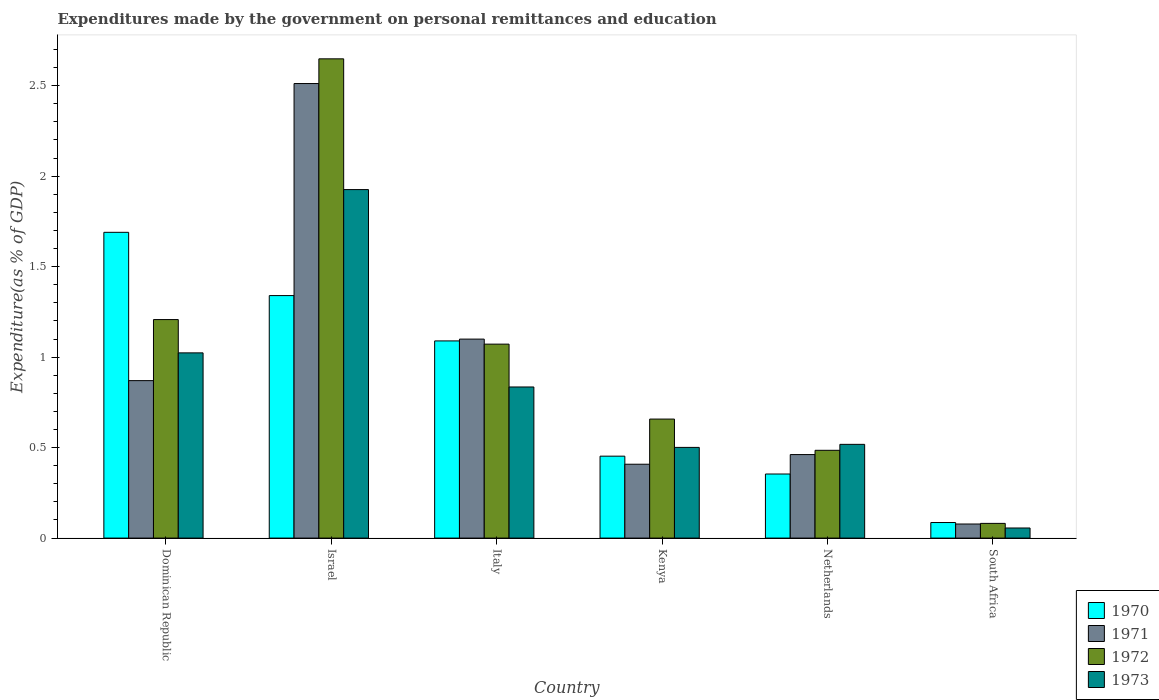How many different coloured bars are there?
Make the answer very short. 4. Are the number of bars per tick equal to the number of legend labels?
Your answer should be compact. Yes. Are the number of bars on each tick of the X-axis equal?
Ensure brevity in your answer.  Yes. How many bars are there on the 2nd tick from the right?
Your answer should be very brief. 4. What is the label of the 1st group of bars from the left?
Give a very brief answer. Dominican Republic. What is the expenditures made by the government on personal remittances and education in 1972 in Italy?
Provide a succinct answer. 1.07. Across all countries, what is the maximum expenditures made by the government on personal remittances and education in 1973?
Keep it short and to the point. 1.93. Across all countries, what is the minimum expenditures made by the government on personal remittances and education in 1970?
Offer a terse response. 0.09. In which country was the expenditures made by the government on personal remittances and education in 1972 minimum?
Your response must be concise. South Africa. What is the total expenditures made by the government on personal remittances and education in 1971 in the graph?
Make the answer very short. 5.43. What is the difference between the expenditures made by the government on personal remittances and education in 1973 in Dominican Republic and that in South Africa?
Keep it short and to the point. 0.97. What is the difference between the expenditures made by the government on personal remittances and education in 1970 in South Africa and the expenditures made by the government on personal remittances and education in 1973 in Kenya?
Offer a terse response. -0.42. What is the average expenditures made by the government on personal remittances and education in 1970 per country?
Keep it short and to the point. 0.84. What is the difference between the expenditures made by the government on personal remittances and education of/in 1970 and expenditures made by the government on personal remittances and education of/in 1971 in Israel?
Make the answer very short. -1.17. What is the ratio of the expenditures made by the government on personal remittances and education in 1970 in Netherlands to that in South Africa?
Provide a short and direct response. 4.12. What is the difference between the highest and the second highest expenditures made by the government on personal remittances and education in 1971?
Provide a succinct answer. -0.23. What is the difference between the highest and the lowest expenditures made by the government on personal remittances and education in 1971?
Provide a succinct answer. 2.43. What does the 2nd bar from the right in South Africa represents?
Keep it short and to the point. 1972. What is the difference between two consecutive major ticks on the Y-axis?
Your answer should be very brief. 0.5. Does the graph contain any zero values?
Give a very brief answer. No. How are the legend labels stacked?
Keep it short and to the point. Vertical. What is the title of the graph?
Offer a very short reply. Expenditures made by the government on personal remittances and education. Does "1976" appear as one of the legend labels in the graph?
Provide a short and direct response. No. What is the label or title of the X-axis?
Give a very brief answer. Country. What is the label or title of the Y-axis?
Offer a terse response. Expenditure(as % of GDP). What is the Expenditure(as % of GDP) of 1970 in Dominican Republic?
Provide a short and direct response. 1.69. What is the Expenditure(as % of GDP) of 1971 in Dominican Republic?
Make the answer very short. 0.87. What is the Expenditure(as % of GDP) of 1972 in Dominican Republic?
Keep it short and to the point. 1.21. What is the Expenditure(as % of GDP) in 1973 in Dominican Republic?
Your answer should be very brief. 1.02. What is the Expenditure(as % of GDP) of 1970 in Israel?
Make the answer very short. 1.34. What is the Expenditure(as % of GDP) of 1971 in Israel?
Offer a terse response. 2.51. What is the Expenditure(as % of GDP) in 1972 in Israel?
Make the answer very short. 2.65. What is the Expenditure(as % of GDP) of 1973 in Israel?
Your answer should be compact. 1.93. What is the Expenditure(as % of GDP) in 1970 in Italy?
Offer a terse response. 1.09. What is the Expenditure(as % of GDP) in 1971 in Italy?
Offer a terse response. 1.1. What is the Expenditure(as % of GDP) in 1972 in Italy?
Provide a short and direct response. 1.07. What is the Expenditure(as % of GDP) in 1973 in Italy?
Offer a terse response. 0.84. What is the Expenditure(as % of GDP) of 1970 in Kenya?
Your response must be concise. 0.45. What is the Expenditure(as % of GDP) of 1971 in Kenya?
Your answer should be compact. 0.41. What is the Expenditure(as % of GDP) of 1972 in Kenya?
Give a very brief answer. 0.66. What is the Expenditure(as % of GDP) of 1973 in Kenya?
Ensure brevity in your answer.  0.5. What is the Expenditure(as % of GDP) in 1970 in Netherlands?
Provide a succinct answer. 0.35. What is the Expenditure(as % of GDP) of 1971 in Netherlands?
Your response must be concise. 0.46. What is the Expenditure(as % of GDP) of 1972 in Netherlands?
Offer a terse response. 0.49. What is the Expenditure(as % of GDP) in 1973 in Netherlands?
Offer a terse response. 0.52. What is the Expenditure(as % of GDP) in 1970 in South Africa?
Offer a terse response. 0.09. What is the Expenditure(as % of GDP) in 1971 in South Africa?
Offer a very short reply. 0.08. What is the Expenditure(as % of GDP) in 1972 in South Africa?
Your answer should be very brief. 0.08. What is the Expenditure(as % of GDP) of 1973 in South Africa?
Ensure brevity in your answer.  0.06. Across all countries, what is the maximum Expenditure(as % of GDP) of 1970?
Give a very brief answer. 1.69. Across all countries, what is the maximum Expenditure(as % of GDP) in 1971?
Your answer should be very brief. 2.51. Across all countries, what is the maximum Expenditure(as % of GDP) of 1972?
Ensure brevity in your answer.  2.65. Across all countries, what is the maximum Expenditure(as % of GDP) of 1973?
Ensure brevity in your answer.  1.93. Across all countries, what is the minimum Expenditure(as % of GDP) in 1970?
Ensure brevity in your answer.  0.09. Across all countries, what is the minimum Expenditure(as % of GDP) of 1971?
Your answer should be compact. 0.08. Across all countries, what is the minimum Expenditure(as % of GDP) of 1972?
Your answer should be compact. 0.08. Across all countries, what is the minimum Expenditure(as % of GDP) in 1973?
Your answer should be very brief. 0.06. What is the total Expenditure(as % of GDP) in 1970 in the graph?
Provide a succinct answer. 5.01. What is the total Expenditure(as % of GDP) of 1971 in the graph?
Offer a very short reply. 5.43. What is the total Expenditure(as % of GDP) of 1972 in the graph?
Your response must be concise. 6.15. What is the total Expenditure(as % of GDP) of 1973 in the graph?
Ensure brevity in your answer.  4.86. What is the difference between the Expenditure(as % of GDP) of 1970 in Dominican Republic and that in Israel?
Offer a very short reply. 0.35. What is the difference between the Expenditure(as % of GDP) in 1971 in Dominican Republic and that in Israel?
Provide a short and direct response. -1.64. What is the difference between the Expenditure(as % of GDP) of 1972 in Dominican Republic and that in Israel?
Offer a terse response. -1.44. What is the difference between the Expenditure(as % of GDP) of 1973 in Dominican Republic and that in Israel?
Your response must be concise. -0.9. What is the difference between the Expenditure(as % of GDP) of 1970 in Dominican Republic and that in Italy?
Your answer should be very brief. 0.6. What is the difference between the Expenditure(as % of GDP) of 1971 in Dominican Republic and that in Italy?
Keep it short and to the point. -0.23. What is the difference between the Expenditure(as % of GDP) in 1972 in Dominican Republic and that in Italy?
Provide a succinct answer. 0.14. What is the difference between the Expenditure(as % of GDP) of 1973 in Dominican Republic and that in Italy?
Your answer should be compact. 0.19. What is the difference between the Expenditure(as % of GDP) of 1970 in Dominican Republic and that in Kenya?
Your response must be concise. 1.24. What is the difference between the Expenditure(as % of GDP) in 1971 in Dominican Republic and that in Kenya?
Your response must be concise. 0.46. What is the difference between the Expenditure(as % of GDP) of 1972 in Dominican Republic and that in Kenya?
Keep it short and to the point. 0.55. What is the difference between the Expenditure(as % of GDP) in 1973 in Dominican Republic and that in Kenya?
Make the answer very short. 0.52. What is the difference between the Expenditure(as % of GDP) of 1970 in Dominican Republic and that in Netherlands?
Your response must be concise. 1.34. What is the difference between the Expenditure(as % of GDP) of 1971 in Dominican Republic and that in Netherlands?
Your answer should be very brief. 0.41. What is the difference between the Expenditure(as % of GDP) of 1972 in Dominican Republic and that in Netherlands?
Ensure brevity in your answer.  0.72. What is the difference between the Expenditure(as % of GDP) of 1973 in Dominican Republic and that in Netherlands?
Provide a succinct answer. 0.51. What is the difference between the Expenditure(as % of GDP) of 1970 in Dominican Republic and that in South Africa?
Ensure brevity in your answer.  1.6. What is the difference between the Expenditure(as % of GDP) in 1971 in Dominican Republic and that in South Africa?
Provide a short and direct response. 0.79. What is the difference between the Expenditure(as % of GDP) of 1972 in Dominican Republic and that in South Africa?
Provide a short and direct response. 1.13. What is the difference between the Expenditure(as % of GDP) of 1973 in Dominican Republic and that in South Africa?
Your response must be concise. 0.97. What is the difference between the Expenditure(as % of GDP) of 1970 in Israel and that in Italy?
Ensure brevity in your answer.  0.25. What is the difference between the Expenditure(as % of GDP) of 1971 in Israel and that in Italy?
Provide a short and direct response. 1.41. What is the difference between the Expenditure(as % of GDP) of 1972 in Israel and that in Italy?
Your answer should be very brief. 1.58. What is the difference between the Expenditure(as % of GDP) in 1973 in Israel and that in Italy?
Provide a short and direct response. 1.09. What is the difference between the Expenditure(as % of GDP) in 1970 in Israel and that in Kenya?
Your response must be concise. 0.89. What is the difference between the Expenditure(as % of GDP) of 1971 in Israel and that in Kenya?
Your response must be concise. 2.1. What is the difference between the Expenditure(as % of GDP) of 1972 in Israel and that in Kenya?
Offer a very short reply. 1.99. What is the difference between the Expenditure(as % of GDP) in 1973 in Israel and that in Kenya?
Your response must be concise. 1.42. What is the difference between the Expenditure(as % of GDP) in 1970 in Israel and that in Netherlands?
Your response must be concise. 0.99. What is the difference between the Expenditure(as % of GDP) of 1971 in Israel and that in Netherlands?
Ensure brevity in your answer.  2.05. What is the difference between the Expenditure(as % of GDP) of 1972 in Israel and that in Netherlands?
Offer a very short reply. 2.16. What is the difference between the Expenditure(as % of GDP) in 1973 in Israel and that in Netherlands?
Your answer should be compact. 1.41. What is the difference between the Expenditure(as % of GDP) of 1970 in Israel and that in South Africa?
Provide a succinct answer. 1.25. What is the difference between the Expenditure(as % of GDP) of 1971 in Israel and that in South Africa?
Your response must be concise. 2.43. What is the difference between the Expenditure(as % of GDP) of 1972 in Israel and that in South Africa?
Provide a short and direct response. 2.57. What is the difference between the Expenditure(as % of GDP) in 1973 in Israel and that in South Africa?
Offer a very short reply. 1.87. What is the difference between the Expenditure(as % of GDP) of 1970 in Italy and that in Kenya?
Your response must be concise. 0.64. What is the difference between the Expenditure(as % of GDP) in 1971 in Italy and that in Kenya?
Offer a terse response. 0.69. What is the difference between the Expenditure(as % of GDP) of 1972 in Italy and that in Kenya?
Offer a very short reply. 0.41. What is the difference between the Expenditure(as % of GDP) of 1973 in Italy and that in Kenya?
Ensure brevity in your answer.  0.33. What is the difference between the Expenditure(as % of GDP) of 1970 in Italy and that in Netherlands?
Offer a very short reply. 0.74. What is the difference between the Expenditure(as % of GDP) in 1971 in Italy and that in Netherlands?
Offer a terse response. 0.64. What is the difference between the Expenditure(as % of GDP) of 1972 in Italy and that in Netherlands?
Keep it short and to the point. 0.59. What is the difference between the Expenditure(as % of GDP) in 1973 in Italy and that in Netherlands?
Provide a short and direct response. 0.32. What is the difference between the Expenditure(as % of GDP) in 1971 in Italy and that in South Africa?
Make the answer very short. 1.02. What is the difference between the Expenditure(as % of GDP) in 1972 in Italy and that in South Africa?
Provide a succinct answer. 0.99. What is the difference between the Expenditure(as % of GDP) in 1973 in Italy and that in South Africa?
Provide a succinct answer. 0.78. What is the difference between the Expenditure(as % of GDP) in 1970 in Kenya and that in Netherlands?
Your answer should be very brief. 0.1. What is the difference between the Expenditure(as % of GDP) in 1971 in Kenya and that in Netherlands?
Your answer should be compact. -0.05. What is the difference between the Expenditure(as % of GDP) in 1972 in Kenya and that in Netherlands?
Provide a short and direct response. 0.17. What is the difference between the Expenditure(as % of GDP) in 1973 in Kenya and that in Netherlands?
Your answer should be very brief. -0.02. What is the difference between the Expenditure(as % of GDP) in 1970 in Kenya and that in South Africa?
Make the answer very short. 0.37. What is the difference between the Expenditure(as % of GDP) in 1971 in Kenya and that in South Africa?
Offer a very short reply. 0.33. What is the difference between the Expenditure(as % of GDP) in 1972 in Kenya and that in South Africa?
Ensure brevity in your answer.  0.58. What is the difference between the Expenditure(as % of GDP) of 1973 in Kenya and that in South Africa?
Provide a succinct answer. 0.45. What is the difference between the Expenditure(as % of GDP) in 1970 in Netherlands and that in South Africa?
Offer a terse response. 0.27. What is the difference between the Expenditure(as % of GDP) of 1971 in Netherlands and that in South Africa?
Offer a terse response. 0.38. What is the difference between the Expenditure(as % of GDP) of 1972 in Netherlands and that in South Africa?
Your answer should be very brief. 0.4. What is the difference between the Expenditure(as % of GDP) of 1973 in Netherlands and that in South Africa?
Your answer should be compact. 0.46. What is the difference between the Expenditure(as % of GDP) of 1970 in Dominican Republic and the Expenditure(as % of GDP) of 1971 in Israel?
Make the answer very short. -0.82. What is the difference between the Expenditure(as % of GDP) of 1970 in Dominican Republic and the Expenditure(as % of GDP) of 1972 in Israel?
Offer a very short reply. -0.96. What is the difference between the Expenditure(as % of GDP) of 1970 in Dominican Republic and the Expenditure(as % of GDP) of 1973 in Israel?
Your answer should be very brief. -0.24. What is the difference between the Expenditure(as % of GDP) of 1971 in Dominican Republic and the Expenditure(as % of GDP) of 1972 in Israel?
Give a very brief answer. -1.78. What is the difference between the Expenditure(as % of GDP) of 1971 in Dominican Republic and the Expenditure(as % of GDP) of 1973 in Israel?
Provide a short and direct response. -1.06. What is the difference between the Expenditure(as % of GDP) in 1972 in Dominican Republic and the Expenditure(as % of GDP) in 1973 in Israel?
Make the answer very short. -0.72. What is the difference between the Expenditure(as % of GDP) in 1970 in Dominican Republic and the Expenditure(as % of GDP) in 1971 in Italy?
Offer a terse response. 0.59. What is the difference between the Expenditure(as % of GDP) in 1970 in Dominican Republic and the Expenditure(as % of GDP) in 1972 in Italy?
Offer a terse response. 0.62. What is the difference between the Expenditure(as % of GDP) in 1970 in Dominican Republic and the Expenditure(as % of GDP) in 1973 in Italy?
Provide a short and direct response. 0.85. What is the difference between the Expenditure(as % of GDP) in 1971 in Dominican Republic and the Expenditure(as % of GDP) in 1972 in Italy?
Ensure brevity in your answer.  -0.2. What is the difference between the Expenditure(as % of GDP) of 1971 in Dominican Republic and the Expenditure(as % of GDP) of 1973 in Italy?
Offer a terse response. 0.04. What is the difference between the Expenditure(as % of GDP) of 1972 in Dominican Republic and the Expenditure(as % of GDP) of 1973 in Italy?
Offer a very short reply. 0.37. What is the difference between the Expenditure(as % of GDP) in 1970 in Dominican Republic and the Expenditure(as % of GDP) in 1971 in Kenya?
Ensure brevity in your answer.  1.28. What is the difference between the Expenditure(as % of GDP) in 1970 in Dominican Republic and the Expenditure(as % of GDP) in 1972 in Kenya?
Ensure brevity in your answer.  1.03. What is the difference between the Expenditure(as % of GDP) in 1970 in Dominican Republic and the Expenditure(as % of GDP) in 1973 in Kenya?
Make the answer very short. 1.19. What is the difference between the Expenditure(as % of GDP) of 1971 in Dominican Republic and the Expenditure(as % of GDP) of 1972 in Kenya?
Your response must be concise. 0.21. What is the difference between the Expenditure(as % of GDP) in 1971 in Dominican Republic and the Expenditure(as % of GDP) in 1973 in Kenya?
Keep it short and to the point. 0.37. What is the difference between the Expenditure(as % of GDP) in 1972 in Dominican Republic and the Expenditure(as % of GDP) in 1973 in Kenya?
Ensure brevity in your answer.  0.71. What is the difference between the Expenditure(as % of GDP) of 1970 in Dominican Republic and the Expenditure(as % of GDP) of 1971 in Netherlands?
Make the answer very short. 1.23. What is the difference between the Expenditure(as % of GDP) of 1970 in Dominican Republic and the Expenditure(as % of GDP) of 1972 in Netherlands?
Offer a terse response. 1.2. What is the difference between the Expenditure(as % of GDP) of 1970 in Dominican Republic and the Expenditure(as % of GDP) of 1973 in Netherlands?
Your answer should be very brief. 1.17. What is the difference between the Expenditure(as % of GDP) of 1971 in Dominican Republic and the Expenditure(as % of GDP) of 1972 in Netherlands?
Your response must be concise. 0.39. What is the difference between the Expenditure(as % of GDP) in 1971 in Dominican Republic and the Expenditure(as % of GDP) in 1973 in Netherlands?
Offer a terse response. 0.35. What is the difference between the Expenditure(as % of GDP) in 1972 in Dominican Republic and the Expenditure(as % of GDP) in 1973 in Netherlands?
Offer a very short reply. 0.69. What is the difference between the Expenditure(as % of GDP) in 1970 in Dominican Republic and the Expenditure(as % of GDP) in 1971 in South Africa?
Your answer should be very brief. 1.61. What is the difference between the Expenditure(as % of GDP) of 1970 in Dominican Republic and the Expenditure(as % of GDP) of 1972 in South Africa?
Ensure brevity in your answer.  1.61. What is the difference between the Expenditure(as % of GDP) of 1970 in Dominican Republic and the Expenditure(as % of GDP) of 1973 in South Africa?
Your answer should be compact. 1.63. What is the difference between the Expenditure(as % of GDP) in 1971 in Dominican Republic and the Expenditure(as % of GDP) in 1972 in South Africa?
Make the answer very short. 0.79. What is the difference between the Expenditure(as % of GDP) in 1971 in Dominican Republic and the Expenditure(as % of GDP) in 1973 in South Africa?
Your response must be concise. 0.81. What is the difference between the Expenditure(as % of GDP) of 1972 in Dominican Republic and the Expenditure(as % of GDP) of 1973 in South Africa?
Your answer should be very brief. 1.15. What is the difference between the Expenditure(as % of GDP) in 1970 in Israel and the Expenditure(as % of GDP) in 1971 in Italy?
Make the answer very short. 0.24. What is the difference between the Expenditure(as % of GDP) of 1970 in Israel and the Expenditure(as % of GDP) of 1972 in Italy?
Offer a very short reply. 0.27. What is the difference between the Expenditure(as % of GDP) in 1970 in Israel and the Expenditure(as % of GDP) in 1973 in Italy?
Your answer should be very brief. 0.51. What is the difference between the Expenditure(as % of GDP) in 1971 in Israel and the Expenditure(as % of GDP) in 1972 in Italy?
Make the answer very short. 1.44. What is the difference between the Expenditure(as % of GDP) in 1971 in Israel and the Expenditure(as % of GDP) in 1973 in Italy?
Provide a short and direct response. 1.68. What is the difference between the Expenditure(as % of GDP) of 1972 in Israel and the Expenditure(as % of GDP) of 1973 in Italy?
Your answer should be compact. 1.81. What is the difference between the Expenditure(as % of GDP) in 1970 in Israel and the Expenditure(as % of GDP) in 1971 in Kenya?
Keep it short and to the point. 0.93. What is the difference between the Expenditure(as % of GDP) in 1970 in Israel and the Expenditure(as % of GDP) in 1972 in Kenya?
Provide a succinct answer. 0.68. What is the difference between the Expenditure(as % of GDP) of 1970 in Israel and the Expenditure(as % of GDP) of 1973 in Kenya?
Your answer should be very brief. 0.84. What is the difference between the Expenditure(as % of GDP) in 1971 in Israel and the Expenditure(as % of GDP) in 1972 in Kenya?
Offer a very short reply. 1.85. What is the difference between the Expenditure(as % of GDP) of 1971 in Israel and the Expenditure(as % of GDP) of 1973 in Kenya?
Provide a short and direct response. 2.01. What is the difference between the Expenditure(as % of GDP) of 1972 in Israel and the Expenditure(as % of GDP) of 1973 in Kenya?
Your answer should be very brief. 2.15. What is the difference between the Expenditure(as % of GDP) of 1970 in Israel and the Expenditure(as % of GDP) of 1971 in Netherlands?
Your answer should be very brief. 0.88. What is the difference between the Expenditure(as % of GDP) of 1970 in Israel and the Expenditure(as % of GDP) of 1972 in Netherlands?
Your answer should be very brief. 0.85. What is the difference between the Expenditure(as % of GDP) in 1970 in Israel and the Expenditure(as % of GDP) in 1973 in Netherlands?
Ensure brevity in your answer.  0.82. What is the difference between the Expenditure(as % of GDP) in 1971 in Israel and the Expenditure(as % of GDP) in 1972 in Netherlands?
Offer a terse response. 2.03. What is the difference between the Expenditure(as % of GDP) in 1971 in Israel and the Expenditure(as % of GDP) in 1973 in Netherlands?
Give a very brief answer. 1.99. What is the difference between the Expenditure(as % of GDP) in 1972 in Israel and the Expenditure(as % of GDP) in 1973 in Netherlands?
Provide a short and direct response. 2.13. What is the difference between the Expenditure(as % of GDP) of 1970 in Israel and the Expenditure(as % of GDP) of 1971 in South Africa?
Offer a very short reply. 1.26. What is the difference between the Expenditure(as % of GDP) in 1970 in Israel and the Expenditure(as % of GDP) in 1972 in South Africa?
Keep it short and to the point. 1.26. What is the difference between the Expenditure(as % of GDP) in 1970 in Israel and the Expenditure(as % of GDP) in 1973 in South Africa?
Provide a short and direct response. 1.28. What is the difference between the Expenditure(as % of GDP) in 1971 in Israel and the Expenditure(as % of GDP) in 1972 in South Africa?
Your answer should be compact. 2.43. What is the difference between the Expenditure(as % of GDP) of 1971 in Israel and the Expenditure(as % of GDP) of 1973 in South Africa?
Your response must be concise. 2.46. What is the difference between the Expenditure(as % of GDP) of 1972 in Israel and the Expenditure(as % of GDP) of 1973 in South Africa?
Offer a very short reply. 2.59. What is the difference between the Expenditure(as % of GDP) of 1970 in Italy and the Expenditure(as % of GDP) of 1971 in Kenya?
Your answer should be compact. 0.68. What is the difference between the Expenditure(as % of GDP) in 1970 in Italy and the Expenditure(as % of GDP) in 1972 in Kenya?
Keep it short and to the point. 0.43. What is the difference between the Expenditure(as % of GDP) in 1970 in Italy and the Expenditure(as % of GDP) in 1973 in Kenya?
Your answer should be compact. 0.59. What is the difference between the Expenditure(as % of GDP) in 1971 in Italy and the Expenditure(as % of GDP) in 1972 in Kenya?
Your response must be concise. 0.44. What is the difference between the Expenditure(as % of GDP) of 1971 in Italy and the Expenditure(as % of GDP) of 1973 in Kenya?
Provide a short and direct response. 0.6. What is the difference between the Expenditure(as % of GDP) of 1972 in Italy and the Expenditure(as % of GDP) of 1973 in Kenya?
Provide a succinct answer. 0.57. What is the difference between the Expenditure(as % of GDP) of 1970 in Italy and the Expenditure(as % of GDP) of 1971 in Netherlands?
Keep it short and to the point. 0.63. What is the difference between the Expenditure(as % of GDP) of 1970 in Italy and the Expenditure(as % of GDP) of 1972 in Netherlands?
Offer a terse response. 0.6. What is the difference between the Expenditure(as % of GDP) of 1970 in Italy and the Expenditure(as % of GDP) of 1973 in Netherlands?
Keep it short and to the point. 0.57. What is the difference between the Expenditure(as % of GDP) in 1971 in Italy and the Expenditure(as % of GDP) in 1972 in Netherlands?
Make the answer very short. 0.61. What is the difference between the Expenditure(as % of GDP) of 1971 in Italy and the Expenditure(as % of GDP) of 1973 in Netherlands?
Keep it short and to the point. 0.58. What is the difference between the Expenditure(as % of GDP) of 1972 in Italy and the Expenditure(as % of GDP) of 1973 in Netherlands?
Keep it short and to the point. 0.55. What is the difference between the Expenditure(as % of GDP) in 1970 in Italy and the Expenditure(as % of GDP) in 1971 in South Africa?
Ensure brevity in your answer.  1.01. What is the difference between the Expenditure(as % of GDP) of 1970 in Italy and the Expenditure(as % of GDP) of 1972 in South Africa?
Your answer should be very brief. 1.01. What is the difference between the Expenditure(as % of GDP) in 1970 in Italy and the Expenditure(as % of GDP) in 1973 in South Africa?
Make the answer very short. 1.03. What is the difference between the Expenditure(as % of GDP) of 1971 in Italy and the Expenditure(as % of GDP) of 1972 in South Africa?
Offer a very short reply. 1.02. What is the difference between the Expenditure(as % of GDP) in 1971 in Italy and the Expenditure(as % of GDP) in 1973 in South Africa?
Offer a terse response. 1.04. What is the difference between the Expenditure(as % of GDP) of 1972 in Italy and the Expenditure(as % of GDP) of 1973 in South Africa?
Your answer should be very brief. 1.02. What is the difference between the Expenditure(as % of GDP) of 1970 in Kenya and the Expenditure(as % of GDP) of 1971 in Netherlands?
Your answer should be very brief. -0.01. What is the difference between the Expenditure(as % of GDP) of 1970 in Kenya and the Expenditure(as % of GDP) of 1972 in Netherlands?
Ensure brevity in your answer.  -0.03. What is the difference between the Expenditure(as % of GDP) in 1970 in Kenya and the Expenditure(as % of GDP) in 1973 in Netherlands?
Provide a short and direct response. -0.07. What is the difference between the Expenditure(as % of GDP) in 1971 in Kenya and the Expenditure(as % of GDP) in 1972 in Netherlands?
Your answer should be compact. -0.08. What is the difference between the Expenditure(as % of GDP) of 1971 in Kenya and the Expenditure(as % of GDP) of 1973 in Netherlands?
Ensure brevity in your answer.  -0.11. What is the difference between the Expenditure(as % of GDP) of 1972 in Kenya and the Expenditure(as % of GDP) of 1973 in Netherlands?
Provide a short and direct response. 0.14. What is the difference between the Expenditure(as % of GDP) of 1970 in Kenya and the Expenditure(as % of GDP) of 1972 in South Africa?
Your answer should be very brief. 0.37. What is the difference between the Expenditure(as % of GDP) in 1970 in Kenya and the Expenditure(as % of GDP) in 1973 in South Africa?
Offer a very short reply. 0.4. What is the difference between the Expenditure(as % of GDP) of 1971 in Kenya and the Expenditure(as % of GDP) of 1972 in South Africa?
Offer a terse response. 0.33. What is the difference between the Expenditure(as % of GDP) in 1971 in Kenya and the Expenditure(as % of GDP) in 1973 in South Africa?
Provide a succinct answer. 0.35. What is the difference between the Expenditure(as % of GDP) of 1972 in Kenya and the Expenditure(as % of GDP) of 1973 in South Africa?
Provide a succinct answer. 0.6. What is the difference between the Expenditure(as % of GDP) in 1970 in Netherlands and the Expenditure(as % of GDP) in 1971 in South Africa?
Provide a short and direct response. 0.28. What is the difference between the Expenditure(as % of GDP) in 1970 in Netherlands and the Expenditure(as % of GDP) in 1972 in South Africa?
Ensure brevity in your answer.  0.27. What is the difference between the Expenditure(as % of GDP) of 1970 in Netherlands and the Expenditure(as % of GDP) of 1973 in South Africa?
Your answer should be very brief. 0.3. What is the difference between the Expenditure(as % of GDP) of 1971 in Netherlands and the Expenditure(as % of GDP) of 1972 in South Africa?
Offer a very short reply. 0.38. What is the difference between the Expenditure(as % of GDP) in 1971 in Netherlands and the Expenditure(as % of GDP) in 1973 in South Africa?
Your answer should be compact. 0.41. What is the difference between the Expenditure(as % of GDP) of 1972 in Netherlands and the Expenditure(as % of GDP) of 1973 in South Africa?
Offer a very short reply. 0.43. What is the average Expenditure(as % of GDP) in 1970 per country?
Your answer should be compact. 0.84. What is the average Expenditure(as % of GDP) in 1971 per country?
Make the answer very short. 0.9. What is the average Expenditure(as % of GDP) of 1972 per country?
Make the answer very short. 1.03. What is the average Expenditure(as % of GDP) in 1973 per country?
Provide a succinct answer. 0.81. What is the difference between the Expenditure(as % of GDP) of 1970 and Expenditure(as % of GDP) of 1971 in Dominican Republic?
Offer a terse response. 0.82. What is the difference between the Expenditure(as % of GDP) of 1970 and Expenditure(as % of GDP) of 1972 in Dominican Republic?
Give a very brief answer. 0.48. What is the difference between the Expenditure(as % of GDP) in 1970 and Expenditure(as % of GDP) in 1973 in Dominican Republic?
Your response must be concise. 0.67. What is the difference between the Expenditure(as % of GDP) of 1971 and Expenditure(as % of GDP) of 1972 in Dominican Republic?
Offer a terse response. -0.34. What is the difference between the Expenditure(as % of GDP) in 1971 and Expenditure(as % of GDP) in 1973 in Dominican Republic?
Keep it short and to the point. -0.15. What is the difference between the Expenditure(as % of GDP) in 1972 and Expenditure(as % of GDP) in 1973 in Dominican Republic?
Offer a terse response. 0.18. What is the difference between the Expenditure(as % of GDP) of 1970 and Expenditure(as % of GDP) of 1971 in Israel?
Make the answer very short. -1.17. What is the difference between the Expenditure(as % of GDP) of 1970 and Expenditure(as % of GDP) of 1972 in Israel?
Ensure brevity in your answer.  -1.31. What is the difference between the Expenditure(as % of GDP) in 1970 and Expenditure(as % of GDP) in 1973 in Israel?
Give a very brief answer. -0.59. What is the difference between the Expenditure(as % of GDP) in 1971 and Expenditure(as % of GDP) in 1972 in Israel?
Your answer should be very brief. -0.14. What is the difference between the Expenditure(as % of GDP) in 1971 and Expenditure(as % of GDP) in 1973 in Israel?
Offer a terse response. 0.59. What is the difference between the Expenditure(as % of GDP) in 1972 and Expenditure(as % of GDP) in 1973 in Israel?
Keep it short and to the point. 0.72. What is the difference between the Expenditure(as % of GDP) in 1970 and Expenditure(as % of GDP) in 1971 in Italy?
Offer a terse response. -0.01. What is the difference between the Expenditure(as % of GDP) of 1970 and Expenditure(as % of GDP) of 1972 in Italy?
Provide a succinct answer. 0.02. What is the difference between the Expenditure(as % of GDP) of 1970 and Expenditure(as % of GDP) of 1973 in Italy?
Your answer should be very brief. 0.25. What is the difference between the Expenditure(as % of GDP) in 1971 and Expenditure(as % of GDP) in 1972 in Italy?
Offer a very short reply. 0.03. What is the difference between the Expenditure(as % of GDP) of 1971 and Expenditure(as % of GDP) of 1973 in Italy?
Offer a terse response. 0.26. What is the difference between the Expenditure(as % of GDP) in 1972 and Expenditure(as % of GDP) in 1973 in Italy?
Ensure brevity in your answer.  0.24. What is the difference between the Expenditure(as % of GDP) of 1970 and Expenditure(as % of GDP) of 1971 in Kenya?
Ensure brevity in your answer.  0.04. What is the difference between the Expenditure(as % of GDP) in 1970 and Expenditure(as % of GDP) in 1972 in Kenya?
Offer a very short reply. -0.2. What is the difference between the Expenditure(as % of GDP) in 1970 and Expenditure(as % of GDP) in 1973 in Kenya?
Your response must be concise. -0.05. What is the difference between the Expenditure(as % of GDP) in 1971 and Expenditure(as % of GDP) in 1972 in Kenya?
Ensure brevity in your answer.  -0.25. What is the difference between the Expenditure(as % of GDP) in 1971 and Expenditure(as % of GDP) in 1973 in Kenya?
Ensure brevity in your answer.  -0.09. What is the difference between the Expenditure(as % of GDP) of 1972 and Expenditure(as % of GDP) of 1973 in Kenya?
Offer a terse response. 0.16. What is the difference between the Expenditure(as % of GDP) of 1970 and Expenditure(as % of GDP) of 1971 in Netherlands?
Provide a succinct answer. -0.11. What is the difference between the Expenditure(as % of GDP) of 1970 and Expenditure(as % of GDP) of 1972 in Netherlands?
Keep it short and to the point. -0.13. What is the difference between the Expenditure(as % of GDP) in 1970 and Expenditure(as % of GDP) in 1973 in Netherlands?
Make the answer very short. -0.16. What is the difference between the Expenditure(as % of GDP) of 1971 and Expenditure(as % of GDP) of 1972 in Netherlands?
Your answer should be very brief. -0.02. What is the difference between the Expenditure(as % of GDP) in 1971 and Expenditure(as % of GDP) in 1973 in Netherlands?
Your answer should be compact. -0.06. What is the difference between the Expenditure(as % of GDP) of 1972 and Expenditure(as % of GDP) of 1973 in Netherlands?
Provide a short and direct response. -0.03. What is the difference between the Expenditure(as % of GDP) in 1970 and Expenditure(as % of GDP) in 1971 in South Africa?
Offer a terse response. 0.01. What is the difference between the Expenditure(as % of GDP) in 1970 and Expenditure(as % of GDP) in 1972 in South Africa?
Ensure brevity in your answer.  0. What is the difference between the Expenditure(as % of GDP) of 1970 and Expenditure(as % of GDP) of 1973 in South Africa?
Your answer should be very brief. 0.03. What is the difference between the Expenditure(as % of GDP) in 1971 and Expenditure(as % of GDP) in 1972 in South Africa?
Ensure brevity in your answer.  -0. What is the difference between the Expenditure(as % of GDP) in 1971 and Expenditure(as % of GDP) in 1973 in South Africa?
Give a very brief answer. 0.02. What is the difference between the Expenditure(as % of GDP) in 1972 and Expenditure(as % of GDP) in 1973 in South Africa?
Provide a succinct answer. 0.03. What is the ratio of the Expenditure(as % of GDP) in 1970 in Dominican Republic to that in Israel?
Give a very brief answer. 1.26. What is the ratio of the Expenditure(as % of GDP) in 1971 in Dominican Republic to that in Israel?
Your answer should be compact. 0.35. What is the ratio of the Expenditure(as % of GDP) in 1972 in Dominican Republic to that in Israel?
Provide a short and direct response. 0.46. What is the ratio of the Expenditure(as % of GDP) of 1973 in Dominican Republic to that in Israel?
Keep it short and to the point. 0.53. What is the ratio of the Expenditure(as % of GDP) of 1970 in Dominican Republic to that in Italy?
Provide a short and direct response. 1.55. What is the ratio of the Expenditure(as % of GDP) in 1971 in Dominican Republic to that in Italy?
Provide a succinct answer. 0.79. What is the ratio of the Expenditure(as % of GDP) of 1972 in Dominican Republic to that in Italy?
Provide a succinct answer. 1.13. What is the ratio of the Expenditure(as % of GDP) in 1973 in Dominican Republic to that in Italy?
Make the answer very short. 1.23. What is the ratio of the Expenditure(as % of GDP) in 1970 in Dominican Republic to that in Kenya?
Offer a very short reply. 3.73. What is the ratio of the Expenditure(as % of GDP) of 1971 in Dominican Republic to that in Kenya?
Ensure brevity in your answer.  2.13. What is the ratio of the Expenditure(as % of GDP) in 1972 in Dominican Republic to that in Kenya?
Your response must be concise. 1.84. What is the ratio of the Expenditure(as % of GDP) of 1973 in Dominican Republic to that in Kenya?
Provide a succinct answer. 2.04. What is the ratio of the Expenditure(as % of GDP) in 1970 in Dominican Republic to that in Netherlands?
Provide a succinct answer. 4.77. What is the ratio of the Expenditure(as % of GDP) of 1971 in Dominican Republic to that in Netherlands?
Your answer should be very brief. 1.89. What is the ratio of the Expenditure(as % of GDP) in 1972 in Dominican Republic to that in Netherlands?
Your response must be concise. 2.49. What is the ratio of the Expenditure(as % of GDP) in 1973 in Dominican Republic to that in Netherlands?
Provide a succinct answer. 1.98. What is the ratio of the Expenditure(as % of GDP) in 1970 in Dominican Republic to that in South Africa?
Offer a very short reply. 19.65. What is the ratio of the Expenditure(as % of GDP) in 1971 in Dominican Republic to that in South Africa?
Your answer should be compact. 11.18. What is the ratio of the Expenditure(as % of GDP) of 1972 in Dominican Republic to that in South Africa?
Offer a terse response. 14.85. What is the ratio of the Expenditure(as % of GDP) in 1973 in Dominican Republic to that in South Africa?
Your answer should be compact. 18.34. What is the ratio of the Expenditure(as % of GDP) in 1970 in Israel to that in Italy?
Provide a succinct answer. 1.23. What is the ratio of the Expenditure(as % of GDP) in 1971 in Israel to that in Italy?
Provide a short and direct response. 2.28. What is the ratio of the Expenditure(as % of GDP) in 1972 in Israel to that in Italy?
Your answer should be compact. 2.47. What is the ratio of the Expenditure(as % of GDP) in 1973 in Israel to that in Italy?
Your answer should be very brief. 2.31. What is the ratio of the Expenditure(as % of GDP) in 1970 in Israel to that in Kenya?
Provide a succinct answer. 2.96. What is the ratio of the Expenditure(as % of GDP) of 1971 in Israel to that in Kenya?
Provide a succinct answer. 6.15. What is the ratio of the Expenditure(as % of GDP) of 1972 in Israel to that in Kenya?
Keep it short and to the point. 4.03. What is the ratio of the Expenditure(as % of GDP) in 1973 in Israel to that in Kenya?
Offer a very short reply. 3.84. What is the ratio of the Expenditure(as % of GDP) in 1970 in Israel to that in Netherlands?
Your answer should be very brief. 3.78. What is the ratio of the Expenditure(as % of GDP) of 1971 in Israel to that in Netherlands?
Provide a short and direct response. 5.44. What is the ratio of the Expenditure(as % of GDP) of 1972 in Israel to that in Netherlands?
Your response must be concise. 5.46. What is the ratio of the Expenditure(as % of GDP) of 1973 in Israel to that in Netherlands?
Give a very brief answer. 3.72. What is the ratio of the Expenditure(as % of GDP) of 1970 in Israel to that in South Africa?
Your response must be concise. 15.58. What is the ratio of the Expenditure(as % of GDP) of 1971 in Israel to that in South Africa?
Your answer should be compact. 32.29. What is the ratio of the Expenditure(as % of GDP) of 1972 in Israel to that in South Africa?
Ensure brevity in your answer.  32.58. What is the ratio of the Expenditure(as % of GDP) in 1973 in Israel to that in South Africa?
Provide a succinct answer. 34.5. What is the ratio of the Expenditure(as % of GDP) in 1970 in Italy to that in Kenya?
Provide a short and direct response. 2.41. What is the ratio of the Expenditure(as % of GDP) in 1971 in Italy to that in Kenya?
Ensure brevity in your answer.  2.69. What is the ratio of the Expenditure(as % of GDP) of 1972 in Italy to that in Kenya?
Offer a terse response. 1.63. What is the ratio of the Expenditure(as % of GDP) of 1973 in Italy to that in Kenya?
Offer a very short reply. 1.67. What is the ratio of the Expenditure(as % of GDP) in 1970 in Italy to that in Netherlands?
Give a very brief answer. 3.08. What is the ratio of the Expenditure(as % of GDP) of 1971 in Italy to that in Netherlands?
Offer a terse response. 2.38. What is the ratio of the Expenditure(as % of GDP) of 1972 in Italy to that in Netherlands?
Your response must be concise. 2.21. What is the ratio of the Expenditure(as % of GDP) in 1973 in Italy to that in Netherlands?
Provide a succinct answer. 1.61. What is the ratio of the Expenditure(as % of GDP) in 1970 in Italy to that in South Africa?
Provide a succinct answer. 12.67. What is the ratio of the Expenditure(as % of GDP) in 1971 in Italy to that in South Africa?
Ensure brevity in your answer.  14.13. What is the ratio of the Expenditure(as % of GDP) in 1972 in Italy to that in South Africa?
Your response must be concise. 13.18. What is the ratio of the Expenditure(as % of GDP) in 1973 in Italy to that in South Africa?
Keep it short and to the point. 14.96. What is the ratio of the Expenditure(as % of GDP) of 1970 in Kenya to that in Netherlands?
Give a very brief answer. 1.28. What is the ratio of the Expenditure(as % of GDP) in 1971 in Kenya to that in Netherlands?
Offer a terse response. 0.88. What is the ratio of the Expenditure(as % of GDP) of 1972 in Kenya to that in Netherlands?
Provide a short and direct response. 1.36. What is the ratio of the Expenditure(as % of GDP) in 1973 in Kenya to that in Netherlands?
Offer a terse response. 0.97. What is the ratio of the Expenditure(as % of GDP) of 1970 in Kenya to that in South Africa?
Offer a terse response. 5.26. What is the ratio of the Expenditure(as % of GDP) in 1971 in Kenya to that in South Africa?
Offer a very short reply. 5.25. What is the ratio of the Expenditure(as % of GDP) of 1972 in Kenya to that in South Africa?
Your response must be concise. 8.09. What is the ratio of the Expenditure(as % of GDP) in 1973 in Kenya to that in South Africa?
Offer a terse response. 8.98. What is the ratio of the Expenditure(as % of GDP) of 1970 in Netherlands to that in South Africa?
Your answer should be compact. 4.12. What is the ratio of the Expenditure(as % of GDP) in 1971 in Netherlands to that in South Africa?
Make the answer very short. 5.93. What is the ratio of the Expenditure(as % of GDP) of 1972 in Netherlands to that in South Africa?
Keep it short and to the point. 5.97. What is the ratio of the Expenditure(as % of GDP) of 1973 in Netherlands to that in South Africa?
Give a very brief answer. 9.28. What is the difference between the highest and the second highest Expenditure(as % of GDP) in 1970?
Keep it short and to the point. 0.35. What is the difference between the highest and the second highest Expenditure(as % of GDP) in 1971?
Keep it short and to the point. 1.41. What is the difference between the highest and the second highest Expenditure(as % of GDP) of 1972?
Ensure brevity in your answer.  1.44. What is the difference between the highest and the second highest Expenditure(as % of GDP) in 1973?
Your answer should be very brief. 0.9. What is the difference between the highest and the lowest Expenditure(as % of GDP) in 1970?
Your answer should be compact. 1.6. What is the difference between the highest and the lowest Expenditure(as % of GDP) in 1971?
Provide a short and direct response. 2.43. What is the difference between the highest and the lowest Expenditure(as % of GDP) of 1972?
Keep it short and to the point. 2.57. What is the difference between the highest and the lowest Expenditure(as % of GDP) of 1973?
Offer a very short reply. 1.87. 